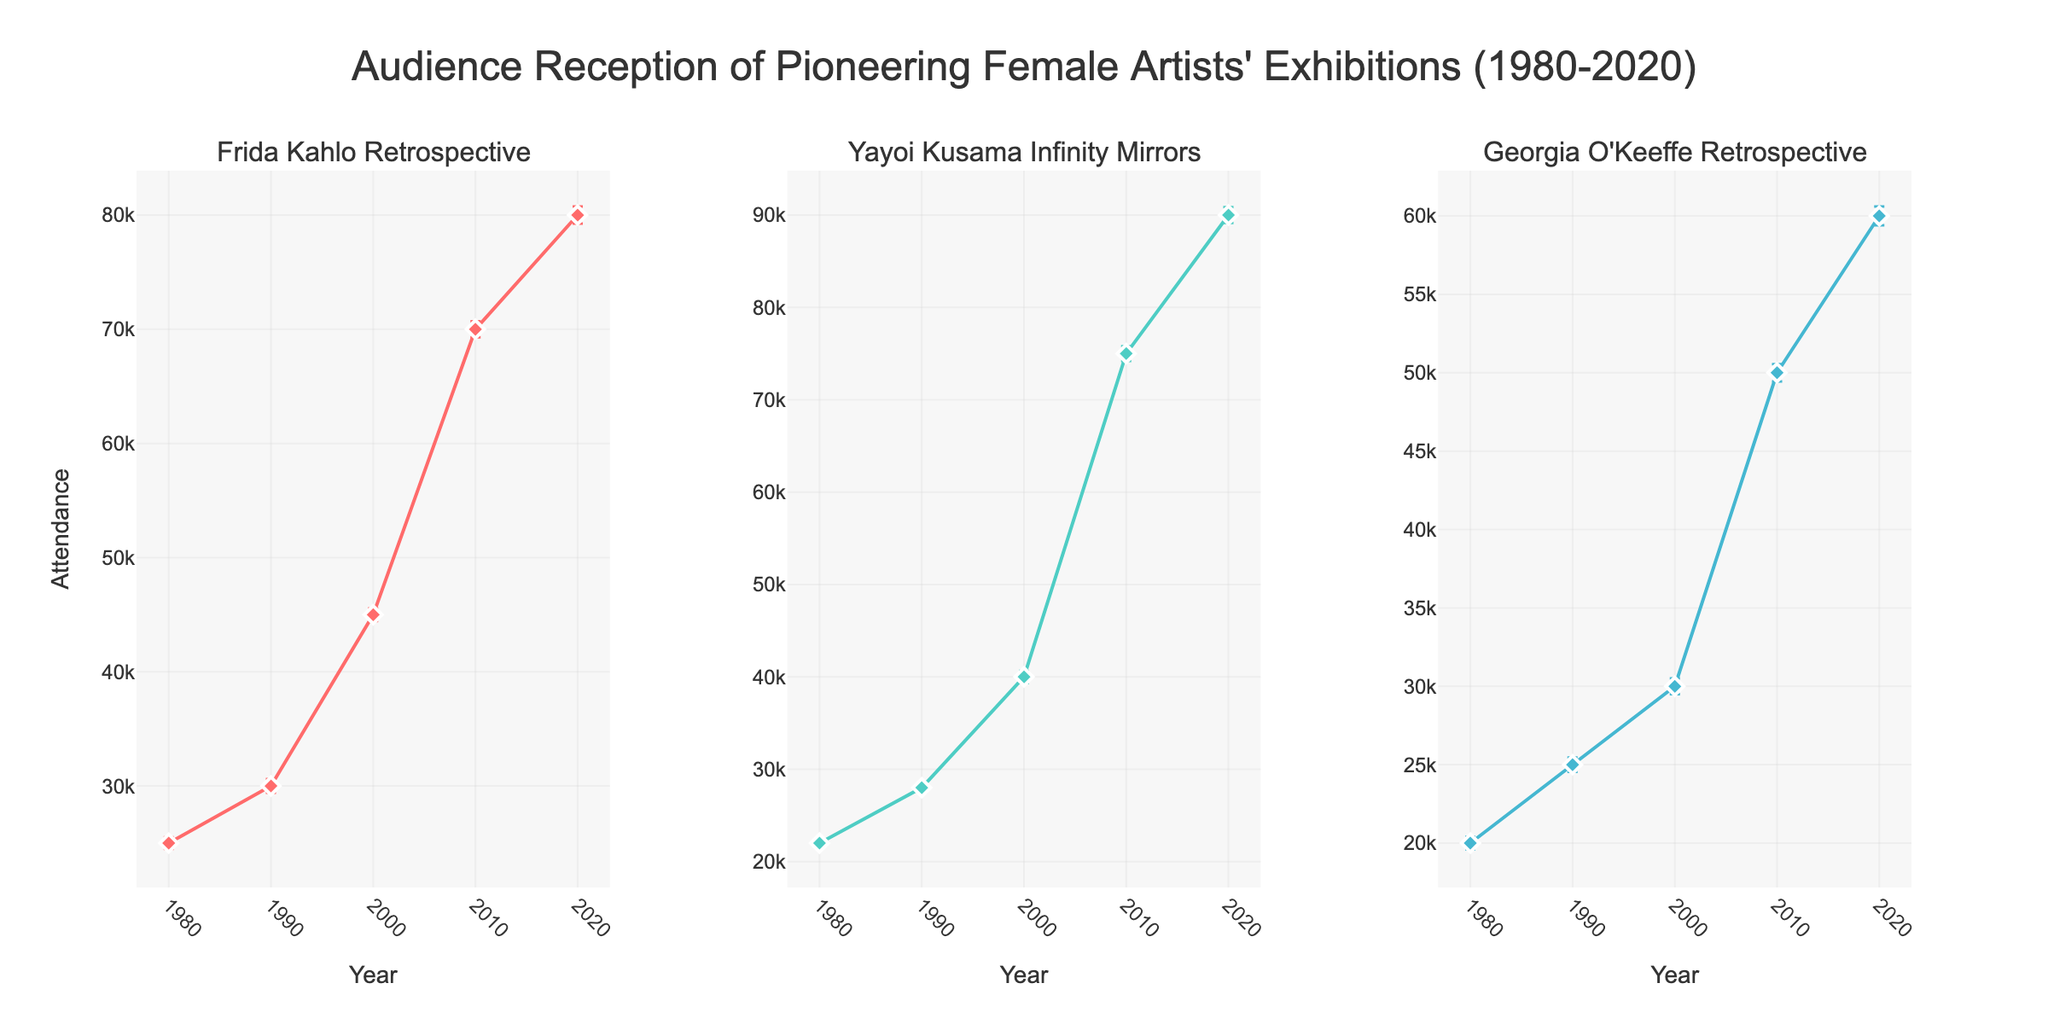What is the title of the figure? The title of the figure is positioned at the top of the plot and summarizes what the figure represents. By looking at the top, we can see the text.
Answer: Audience Reception of Pioneering Female Artists' Exhibitions (1980-2020) How many exhibitions are being compared in the figure? By examining the subplot titles and identifying unique exhibition names, we see three distinct exhibitions.
Answer: Three Which exhibition had the highest attendance in 2020? To determine this, we check the attendance values for each exhibition in 2020. Yayoi Kusama Infinity Mirrors had an attendance of 90,000, which is the highest among the three.
Answer: Yayoi Kusama Infinity Mirrors Which exhibition had the smallest deviation in attendance in 1980? We look at the standard deviation bars for each exhibition in 1980. Georgia O'Keeffe Retrospective had a standard deviation of 400, the smallest among the three.
Answer: Georgia O'Keeffe Retrospective What was the attendance trend for Frida Kahlo Retrospective from 1980 to 2020? We follow the line plot for Frida Kahlo Retrospective from 1980 to 2020. The attendance shows an upward trend, increasing in each decade.
Answer: Increasing What is the difference in attendance between 1990 and 2020 for Georgia O'Keeffe Retrospective? The 1990 attendance was 25,000, and the 2020 attendance was 60,000. Subtracting 25,000 from 60,000 gives the difference.
Answer: 35,000 How does the error bar length compare between Yayoi Kusama Infinity Mirrors in 2010 and 2020? By comparing the lengths of the error bars, we see that the error bar in 2020 is longer than in 2010.
Answer: Longer Which exhibition showed the most dramatic increase in audience attendance over the decades? We observe the trends in attendance for each exhibition and note that Yayoi Kusama Infinity Mirrors had the steepest incline, especially between 2000 to 2020.
Answer: Yayoi Kusama Infinity Mirrors What was the attendance for Georgia O'Keeffe Retrospective in 2000? We locate the data point for Georgia O'Keeffe Retrospective in the year 2000, which shows an attendance of 30,000.
Answer: 30,000 